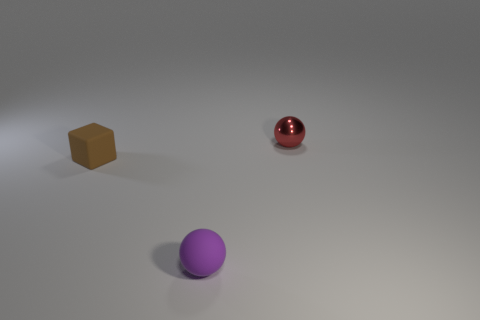Can you describe the color and apparent texture of the sphere closest to the foreground? The sphere closest to the foreground has a purple color with a smooth and slightly reflective texture. Its location and the lighting indicate it might have a matte-like finish. 